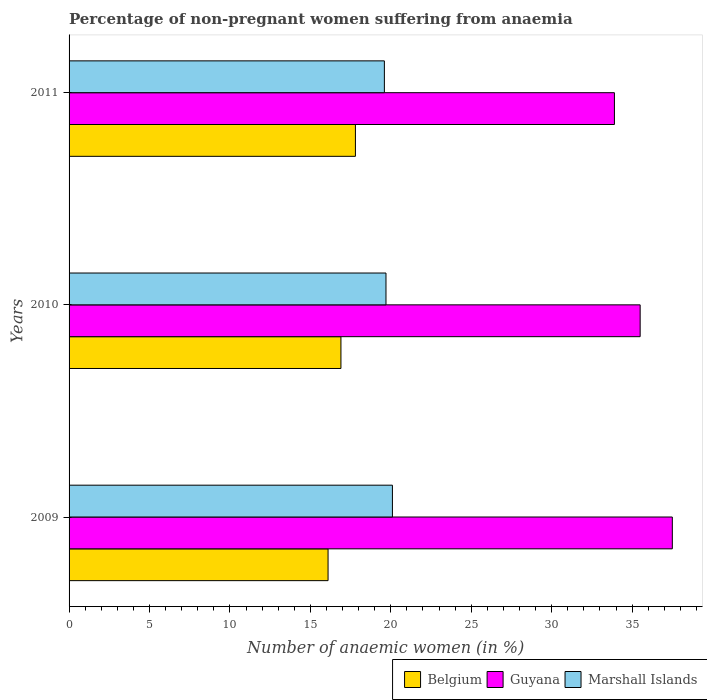How many groups of bars are there?
Ensure brevity in your answer.  3. Are the number of bars per tick equal to the number of legend labels?
Make the answer very short. Yes. How many bars are there on the 3rd tick from the top?
Give a very brief answer. 3. How many bars are there on the 3rd tick from the bottom?
Give a very brief answer. 3. Across all years, what is the maximum percentage of non-pregnant women suffering from anaemia in Marshall Islands?
Give a very brief answer. 20.1. Across all years, what is the minimum percentage of non-pregnant women suffering from anaemia in Guyana?
Keep it short and to the point. 33.9. In which year was the percentage of non-pregnant women suffering from anaemia in Guyana maximum?
Give a very brief answer. 2009. What is the total percentage of non-pregnant women suffering from anaemia in Belgium in the graph?
Offer a very short reply. 50.8. What is the difference between the percentage of non-pregnant women suffering from anaemia in Guyana in 2009 and that in 2010?
Your response must be concise. 2. What is the difference between the percentage of non-pregnant women suffering from anaemia in Belgium in 2009 and the percentage of non-pregnant women suffering from anaemia in Marshall Islands in 2011?
Provide a succinct answer. -3.5. What is the average percentage of non-pregnant women suffering from anaemia in Guyana per year?
Provide a succinct answer. 35.63. In the year 2009, what is the difference between the percentage of non-pregnant women suffering from anaemia in Guyana and percentage of non-pregnant women suffering from anaemia in Belgium?
Ensure brevity in your answer.  21.4. What is the ratio of the percentage of non-pregnant women suffering from anaemia in Guyana in 2010 to that in 2011?
Offer a very short reply. 1.05. Is the difference between the percentage of non-pregnant women suffering from anaemia in Guyana in 2009 and 2011 greater than the difference between the percentage of non-pregnant women suffering from anaemia in Belgium in 2009 and 2011?
Your answer should be very brief. Yes. What is the difference between the highest and the second highest percentage of non-pregnant women suffering from anaemia in Belgium?
Your answer should be compact. 0.9. What is the difference between the highest and the lowest percentage of non-pregnant women suffering from anaemia in Marshall Islands?
Your response must be concise. 0.5. In how many years, is the percentage of non-pregnant women suffering from anaemia in Guyana greater than the average percentage of non-pregnant women suffering from anaemia in Guyana taken over all years?
Offer a terse response. 1. Is the sum of the percentage of non-pregnant women suffering from anaemia in Marshall Islands in 2009 and 2010 greater than the maximum percentage of non-pregnant women suffering from anaemia in Belgium across all years?
Provide a short and direct response. Yes. What does the 2nd bar from the top in 2011 represents?
Ensure brevity in your answer.  Guyana. What does the 2nd bar from the bottom in 2010 represents?
Ensure brevity in your answer.  Guyana. How many bars are there?
Give a very brief answer. 9. Does the graph contain any zero values?
Your answer should be compact. No. How many legend labels are there?
Your answer should be compact. 3. What is the title of the graph?
Your answer should be very brief. Percentage of non-pregnant women suffering from anaemia. Does "Croatia" appear as one of the legend labels in the graph?
Provide a succinct answer. No. What is the label or title of the X-axis?
Your response must be concise. Number of anaemic women (in %). What is the label or title of the Y-axis?
Your answer should be very brief. Years. What is the Number of anaemic women (in %) in Belgium in 2009?
Your response must be concise. 16.1. What is the Number of anaemic women (in %) in Guyana in 2009?
Offer a very short reply. 37.5. What is the Number of anaemic women (in %) in Marshall Islands in 2009?
Your answer should be compact. 20.1. What is the Number of anaemic women (in %) in Belgium in 2010?
Keep it short and to the point. 16.9. What is the Number of anaemic women (in %) in Guyana in 2010?
Your answer should be compact. 35.5. What is the Number of anaemic women (in %) of Belgium in 2011?
Your answer should be very brief. 17.8. What is the Number of anaemic women (in %) of Guyana in 2011?
Offer a very short reply. 33.9. What is the Number of anaemic women (in %) of Marshall Islands in 2011?
Your response must be concise. 19.6. Across all years, what is the maximum Number of anaemic women (in %) of Guyana?
Provide a succinct answer. 37.5. Across all years, what is the maximum Number of anaemic women (in %) of Marshall Islands?
Give a very brief answer. 20.1. Across all years, what is the minimum Number of anaemic women (in %) of Belgium?
Give a very brief answer. 16.1. Across all years, what is the minimum Number of anaemic women (in %) in Guyana?
Ensure brevity in your answer.  33.9. Across all years, what is the minimum Number of anaemic women (in %) in Marshall Islands?
Provide a short and direct response. 19.6. What is the total Number of anaemic women (in %) of Belgium in the graph?
Your answer should be compact. 50.8. What is the total Number of anaemic women (in %) of Guyana in the graph?
Give a very brief answer. 106.9. What is the total Number of anaemic women (in %) in Marshall Islands in the graph?
Your answer should be very brief. 59.4. What is the difference between the Number of anaemic women (in %) of Belgium in 2009 and that in 2010?
Keep it short and to the point. -0.8. What is the difference between the Number of anaemic women (in %) in Marshall Islands in 2009 and that in 2010?
Offer a terse response. 0.4. What is the difference between the Number of anaemic women (in %) in Guyana in 2009 and that in 2011?
Ensure brevity in your answer.  3.6. What is the difference between the Number of anaemic women (in %) of Marshall Islands in 2009 and that in 2011?
Keep it short and to the point. 0.5. What is the difference between the Number of anaemic women (in %) in Belgium in 2009 and the Number of anaemic women (in %) in Guyana in 2010?
Your answer should be very brief. -19.4. What is the difference between the Number of anaemic women (in %) in Belgium in 2009 and the Number of anaemic women (in %) in Marshall Islands in 2010?
Your answer should be compact. -3.6. What is the difference between the Number of anaemic women (in %) of Guyana in 2009 and the Number of anaemic women (in %) of Marshall Islands in 2010?
Your response must be concise. 17.8. What is the difference between the Number of anaemic women (in %) in Belgium in 2009 and the Number of anaemic women (in %) in Guyana in 2011?
Provide a succinct answer. -17.8. What is the difference between the Number of anaemic women (in %) in Belgium in 2009 and the Number of anaemic women (in %) in Marshall Islands in 2011?
Your response must be concise. -3.5. What is the difference between the Number of anaemic women (in %) of Belgium in 2010 and the Number of anaemic women (in %) of Marshall Islands in 2011?
Your response must be concise. -2.7. What is the average Number of anaemic women (in %) in Belgium per year?
Your answer should be compact. 16.93. What is the average Number of anaemic women (in %) in Guyana per year?
Provide a succinct answer. 35.63. What is the average Number of anaemic women (in %) in Marshall Islands per year?
Offer a very short reply. 19.8. In the year 2009, what is the difference between the Number of anaemic women (in %) in Belgium and Number of anaemic women (in %) in Guyana?
Provide a succinct answer. -21.4. In the year 2009, what is the difference between the Number of anaemic women (in %) in Belgium and Number of anaemic women (in %) in Marshall Islands?
Provide a short and direct response. -4. In the year 2009, what is the difference between the Number of anaemic women (in %) in Guyana and Number of anaemic women (in %) in Marshall Islands?
Your answer should be compact. 17.4. In the year 2010, what is the difference between the Number of anaemic women (in %) of Belgium and Number of anaemic women (in %) of Guyana?
Give a very brief answer. -18.6. In the year 2010, what is the difference between the Number of anaemic women (in %) of Guyana and Number of anaemic women (in %) of Marshall Islands?
Ensure brevity in your answer.  15.8. In the year 2011, what is the difference between the Number of anaemic women (in %) of Belgium and Number of anaemic women (in %) of Guyana?
Your response must be concise. -16.1. In the year 2011, what is the difference between the Number of anaemic women (in %) of Belgium and Number of anaemic women (in %) of Marshall Islands?
Your response must be concise. -1.8. In the year 2011, what is the difference between the Number of anaemic women (in %) of Guyana and Number of anaemic women (in %) of Marshall Islands?
Give a very brief answer. 14.3. What is the ratio of the Number of anaemic women (in %) in Belgium in 2009 to that in 2010?
Your answer should be very brief. 0.95. What is the ratio of the Number of anaemic women (in %) in Guyana in 2009 to that in 2010?
Provide a succinct answer. 1.06. What is the ratio of the Number of anaemic women (in %) in Marshall Islands in 2009 to that in 2010?
Offer a very short reply. 1.02. What is the ratio of the Number of anaemic women (in %) of Belgium in 2009 to that in 2011?
Provide a short and direct response. 0.9. What is the ratio of the Number of anaemic women (in %) in Guyana in 2009 to that in 2011?
Ensure brevity in your answer.  1.11. What is the ratio of the Number of anaemic women (in %) in Marshall Islands in 2009 to that in 2011?
Provide a short and direct response. 1.03. What is the ratio of the Number of anaemic women (in %) in Belgium in 2010 to that in 2011?
Make the answer very short. 0.95. What is the ratio of the Number of anaemic women (in %) in Guyana in 2010 to that in 2011?
Provide a succinct answer. 1.05. What is the ratio of the Number of anaemic women (in %) in Marshall Islands in 2010 to that in 2011?
Your answer should be very brief. 1.01. What is the difference between the highest and the second highest Number of anaemic women (in %) in Belgium?
Keep it short and to the point. 0.9. What is the difference between the highest and the second highest Number of anaemic women (in %) of Guyana?
Give a very brief answer. 2. What is the difference between the highest and the second highest Number of anaemic women (in %) in Marshall Islands?
Offer a terse response. 0.4. 